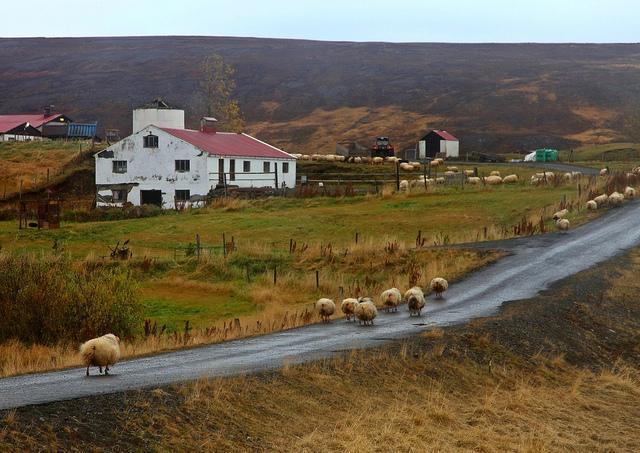What has caused the road to look slick?
Select the accurate response from the four choices given to answer the question.
Options: Snow, rain, ice, wax. Rain. 